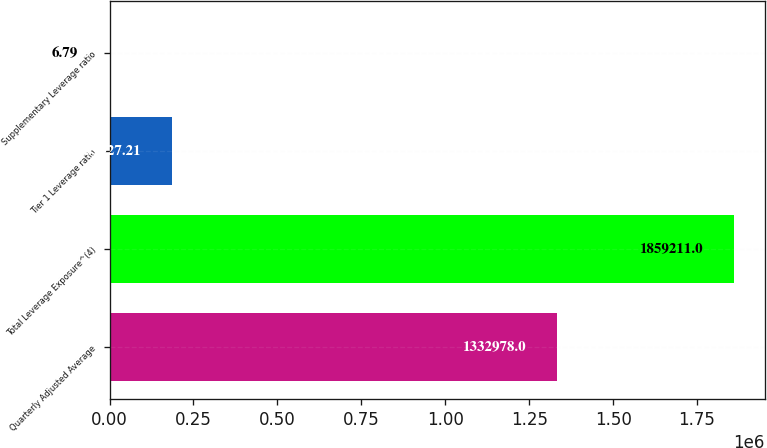Convert chart. <chart><loc_0><loc_0><loc_500><loc_500><bar_chart><fcel>Quarterly Adjusted Average<fcel>Total Leverage Exposure^(4)<fcel>Tier 1 Leverage ratio<fcel>Supplementary Leverage ratio<nl><fcel>1.33298e+06<fcel>1.85921e+06<fcel>185927<fcel>6.79<nl></chart> 